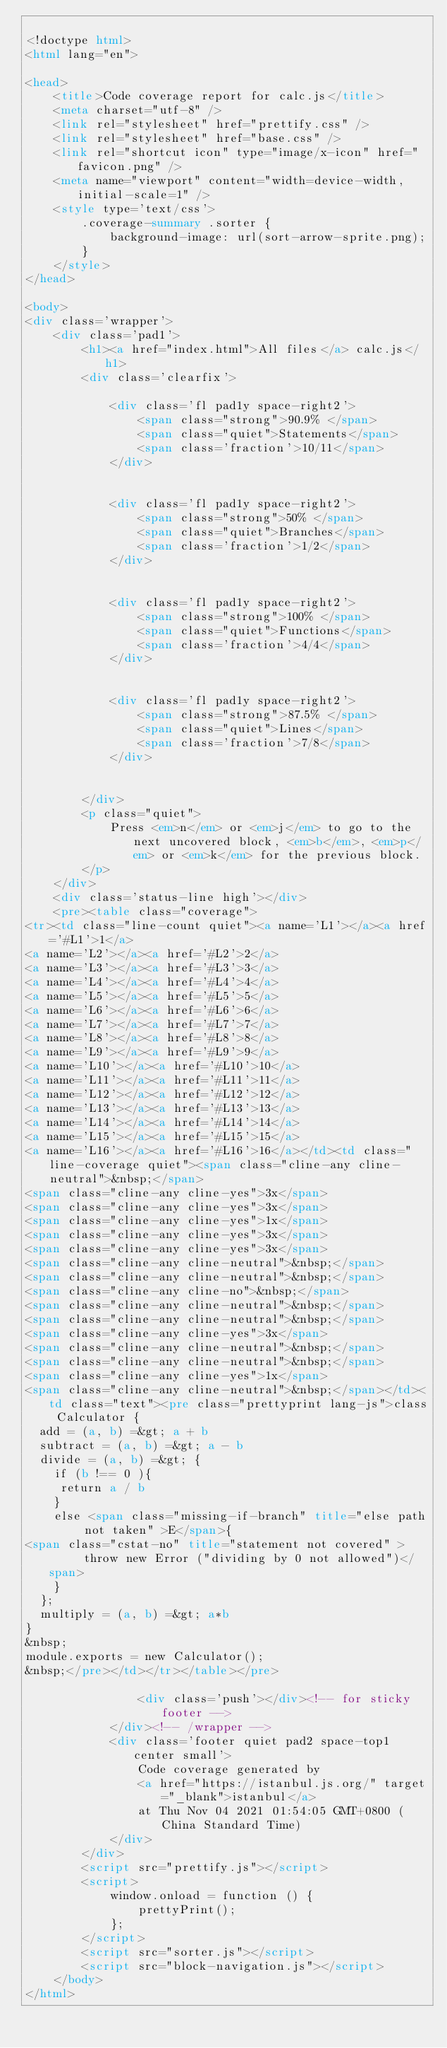Convert code to text. <code><loc_0><loc_0><loc_500><loc_500><_HTML_>
<!doctype html>
<html lang="en">

<head>
    <title>Code coverage report for calc.js</title>
    <meta charset="utf-8" />
    <link rel="stylesheet" href="prettify.css" />
    <link rel="stylesheet" href="base.css" />
    <link rel="shortcut icon" type="image/x-icon" href="favicon.png" />
    <meta name="viewport" content="width=device-width, initial-scale=1" />
    <style type='text/css'>
        .coverage-summary .sorter {
            background-image: url(sort-arrow-sprite.png);
        }
    </style>
</head>
    
<body>
<div class='wrapper'>
    <div class='pad1'>
        <h1><a href="index.html">All files</a> calc.js</h1>
        <div class='clearfix'>
            
            <div class='fl pad1y space-right2'>
                <span class="strong">90.9% </span>
                <span class="quiet">Statements</span>
                <span class='fraction'>10/11</span>
            </div>
        
            
            <div class='fl pad1y space-right2'>
                <span class="strong">50% </span>
                <span class="quiet">Branches</span>
                <span class='fraction'>1/2</span>
            </div>
        
            
            <div class='fl pad1y space-right2'>
                <span class="strong">100% </span>
                <span class="quiet">Functions</span>
                <span class='fraction'>4/4</span>
            </div>
        
            
            <div class='fl pad1y space-right2'>
                <span class="strong">87.5% </span>
                <span class="quiet">Lines</span>
                <span class='fraction'>7/8</span>
            </div>
        
            
        </div>
        <p class="quiet">
            Press <em>n</em> or <em>j</em> to go to the next uncovered block, <em>b</em>, <em>p</em> or <em>k</em> for the previous block.
        </p>
    </div>
    <div class='status-line high'></div>
    <pre><table class="coverage">
<tr><td class="line-count quiet"><a name='L1'></a><a href='#L1'>1</a>
<a name='L2'></a><a href='#L2'>2</a>
<a name='L3'></a><a href='#L3'>3</a>
<a name='L4'></a><a href='#L4'>4</a>
<a name='L5'></a><a href='#L5'>5</a>
<a name='L6'></a><a href='#L6'>6</a>
<a name='L7'></a><a href='#L7'>7</a>
<a name='L8'></a><a href='#L8'>8</a>
<a name='L9'></a><a href='#L9'>9</a>
<a name='L10'></a><a href='#L10'>10</a>
<a name='L11'></a><a href='#L11'>11</a>
<a name='L12'></a><a href='#L12'>12</a>
<a name='L13'></a><a href='#L13'>13</a>
<a name='L14'></a><a href='#L14'>14</a>
<a name='L15'></a><a href='#L15'>15</a>
<a name='L16'></a><a href='#L16'>16</a></td><td class="line-coverage quiet"><span class="cline-any cline-neutral">&nbsp;</span>
<span class="cline-any cline-yes">3x</span>
<span class="cline-any cline-yes">3x</span>
<span class="cline-any cline-yes">1x</span>
<span class="cline-any cline-yes">3x</span>
<span class="cline-any cline-yes">3x</span>
<span class="cline-any cline-neutral">&nbsp;</span>
<span class="cline-any cline-neutral">&nbsp;</span>
<span class="cline-any cline-no">&nbsp;</span>
<span class="cline-any cline-neutral">&nbsp;</span>
<span class="cline-any cline-neutral">&nbsp;</span>
<span class="cline-any cline-yes">3x</span>
<span class="cline-any cline-neutral">&nbsp;</span>
<span class="cline-any cline-neutral">&nbsp;</span>
<span class="cline-any cline-yes">1x</span>
<span class="cline-any cline-neutral">&nbsp;</span></td><td class="text"><pre class="prettyprint lang-js">class Calculator {
  add = (a, b) =&gt; a + b
  subtract = (a, b) =&gt; a - b
  divide = (a, b) =&gt; {
    if (b !== 0 ){
     return a / b
    }
    else <span class="missing-if-branch" title="else path not taken" >E</span>{
<span class="cstat-no" title="statement not covered" >      throw new Error ("dividing by 0 not allowed")</span>
    }
  };
  multiply = (a, b) =&gt; a*b
}
&nbsp;
module.exports = new Calculator();
&nbsp;</pre></td></tr></table></pre>

                <div class='push'></div><!-- for sticky footer -->
            </div><!-- /wrapper -->
            <div class='footer quiet pad2 space-top1 center small'>
                Code coverage generated by
                <a href="https://istanbul.js.org/" target="_blank">istanbul</a>
                at Thu Nov 04 2021 01:54:05 GMT+0800 (China Standard Time)
            </div>
        </div>
        <script src="prettify.js"></script>
        <script>
            window.onload = function () {
                prettyPrint();
            };
        </script>
        <script src="sorter.js"></script>
        <script src="block-navigation.js"></script>
    </body>
</html>
    </code> 